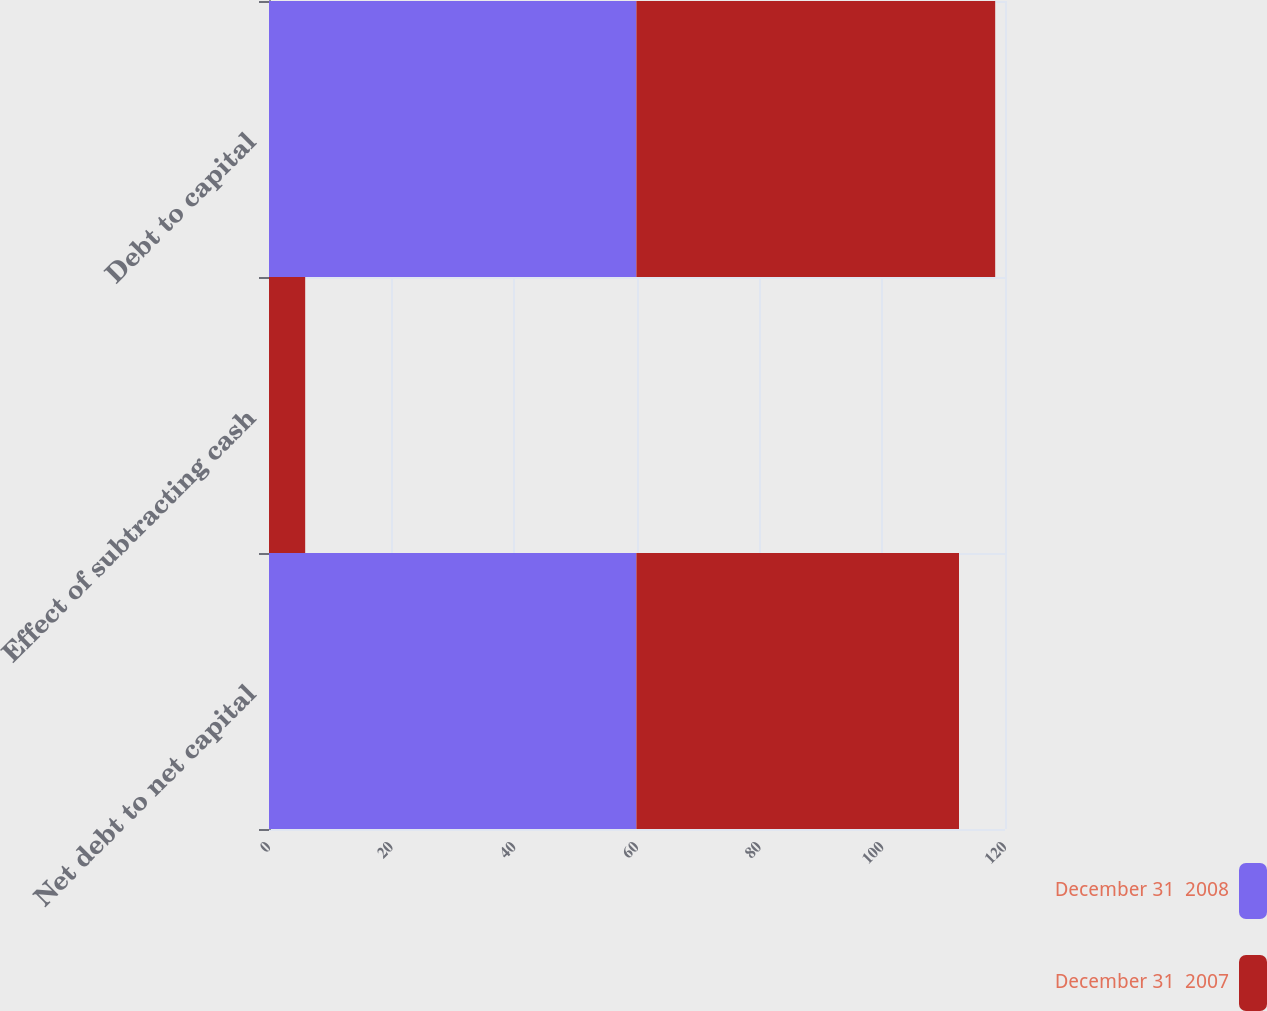Convert chart to OTSL. <chart><loc_0><loc_0><loc_500><loc_500><stacked_bar_chart><ecel><fcel>Net debt to net capital<fcel>Effect of subtracting cash<fcel>Debt to capital<nl><fcel>December 31  2008<fcel>59.9<fcel>0<fcel>59.9<nl><fcel>December 31  2007<fcel>52.6<fcel>5.9<fcel>58.5<nl></chart> 